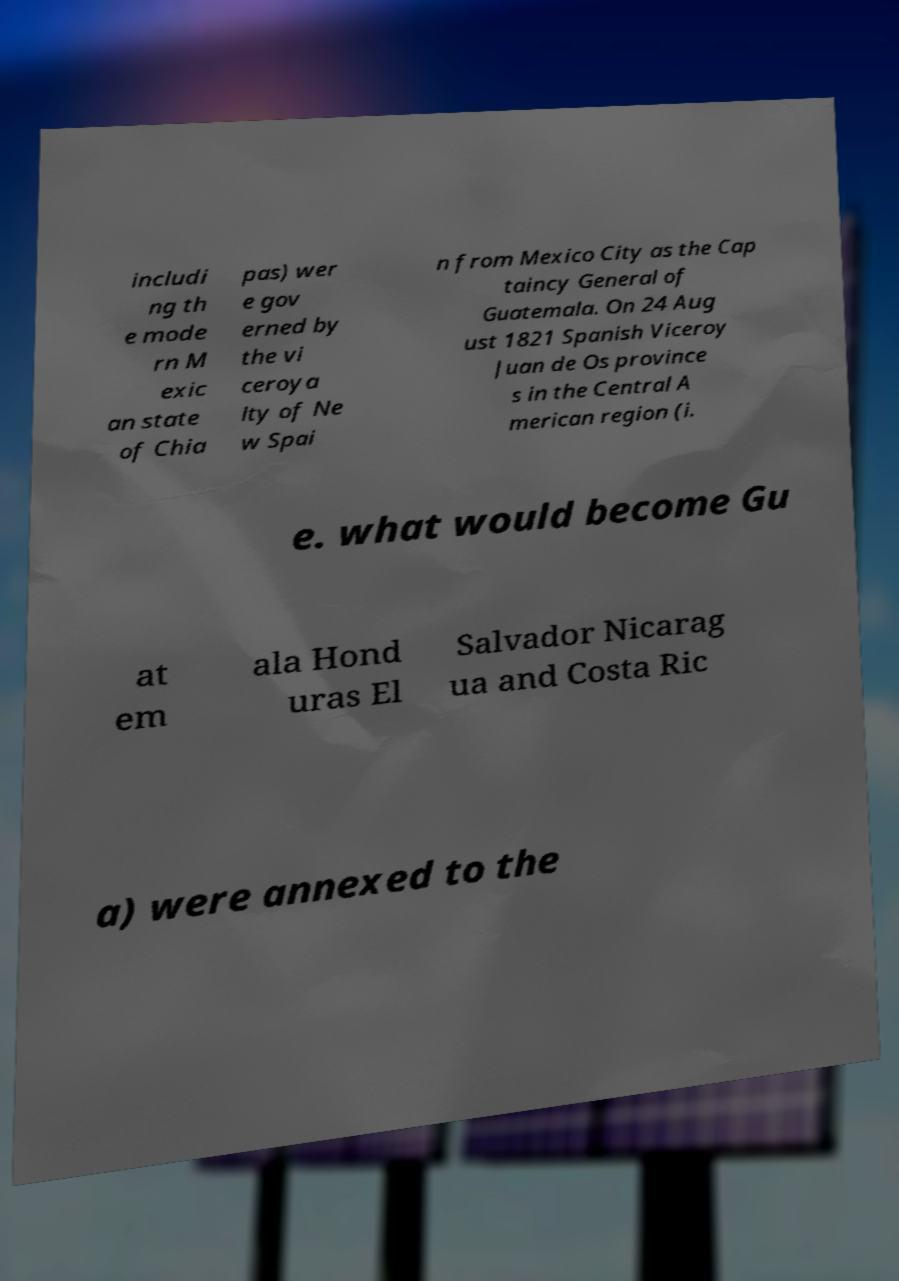Can you accurately transcribe the text from the provided image for me? includi ng th e mode rn M exic an state of Chia pas) wer e gov erned by the vi ceroya lty of Ne w Spai n from Mexico City as the Cap taincy General of Guatemala. On 24 Aug ust 1821 Spanish Viceroy Juan de Os province s in the Central A merican region (i. e. what would become Gu at em ala Hond uras El Salvador Nicarag ua and Costa Ric a) were annexed to the 